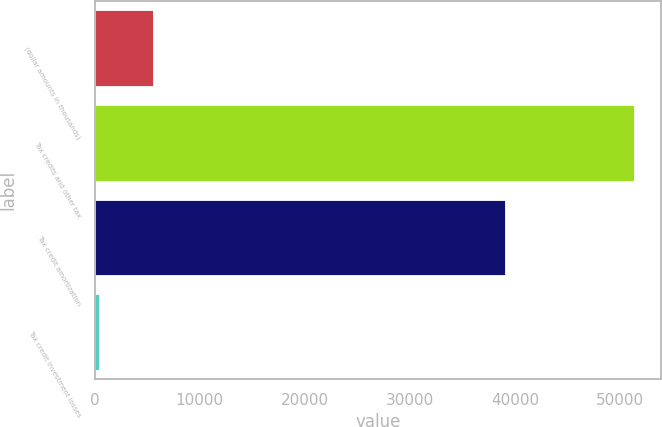Convert chart to OTSL. <chart><loc_0><loc_0><loc_500><loc_500><bar_chart><fcel>(dollar amounts in thousands)<fcel>Tax credits and other tax<fcel>Tax credit amortization<fcel>Tax credit investment losses<nl><fcel>5522.3<fcel>51317<fcel>39021<fcel>434<nl></chart> 